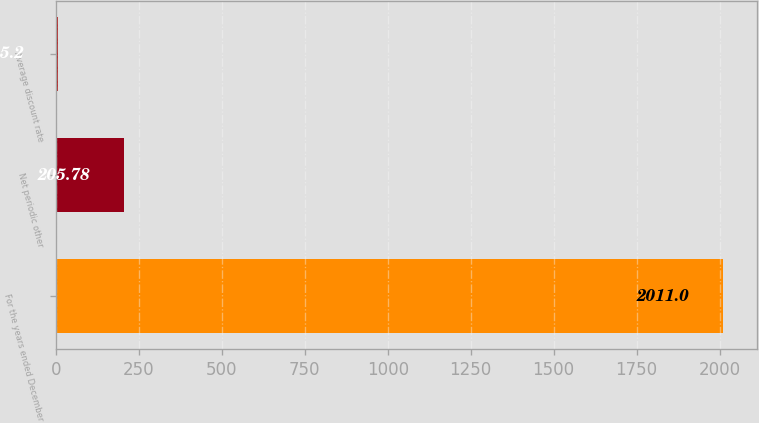Convert chart to OTSL. <chart><loc_0><loc_0><loc_500><loc_500><bar_chart><fcel>For the years ended December<fcel>Net periodic other<fcel>Average discount rate<nl><fcel>2011<fcel>205.78<fcel>5.2<nl></chart> 